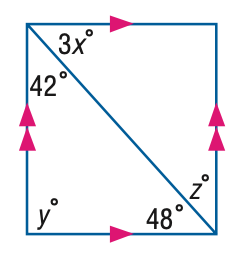Question: Find x in the figure.
Choices:
A. 12
B. 14
C. 16
D. 18
Answer with the letter. Answer: C Question: Find z in the figure.
Choices:
A. 16
B. 36
C. 42
D. 48
Answer with the letter. Answer: C Question: Find y in the figure.
Choices:
A. 42
B. 48
C. 80
D. 90
Answer with the letter. Answer: D 